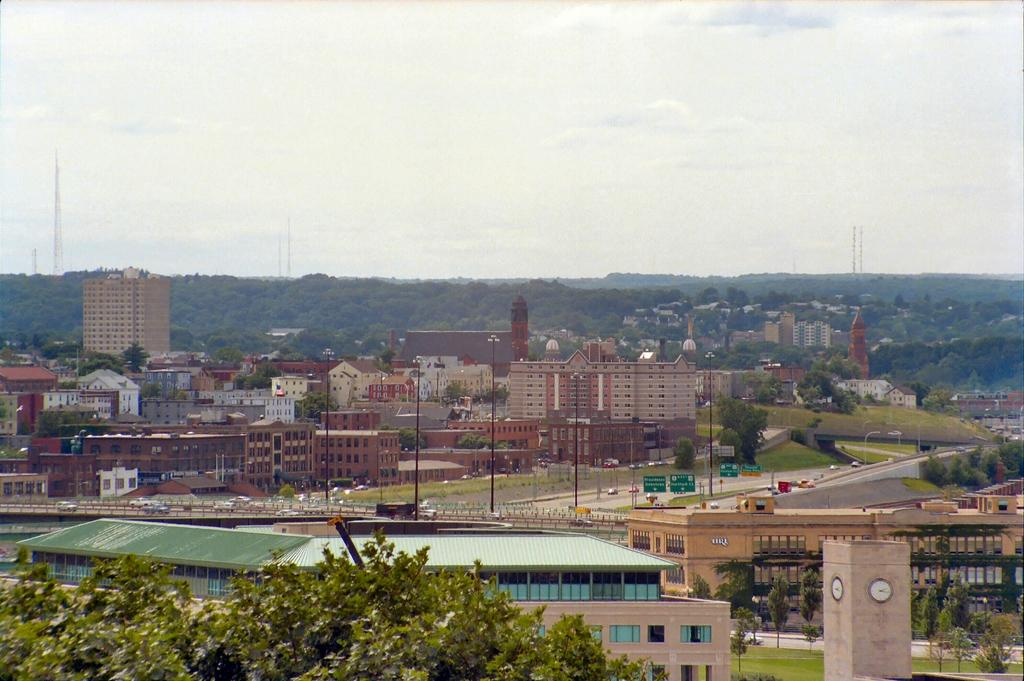What type of structures can be seen in the image? There are buildings in the image. What connects the two sides of the image? There is a bridge in the image. What is happening on the bridge? Vehicles are moving on the bridge. What type of vegetation is present in the image? There are trees in the image. What else can be seen in the image besides buildings and trees? There are poles in the image. What is the condition of the sky in the image? The sky is clear in the image. Where is the camp located in the image? There is no camp present in the image. How many bikes are visible on the bridge in the image? There are no bikes visible on the bridge in the image. 